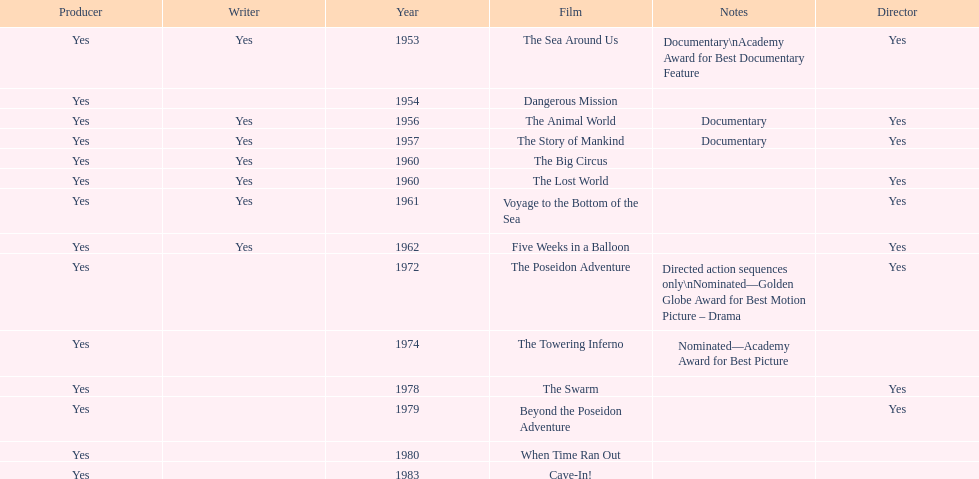How many films did irwin allen direct, produce and write? 6. Can you give me this table as a dict? {'header': ['Producer', 'Writer', 'Year', 'Film', 'Notes', 'Director'], 'rows': [['Yes', 'Yes', '1953', 'The Sea Around Us', 'Documentary\\nAcademy Award for Best Documentary Feature', 'Yes'], ['Yes', '', '1954', 'Dangerous Mission', '', ''], ['Yes', 'Yes', '1956', 'The Animal World', 'Documentary', 'Yes'], ['Yes', 'Yes', '1957', 'The Story of Mankind', 'Documentary', 'Yes'], ['Yes', 'Yes', '1960', 'The Big Circus', '', ''], ['Yes', 'Yes', '1960', 'The Lost World', '', 'Yes'], ['Yes', 'Yes', '1961', 'Voyage to the Bottom of the Sea', '', 'Yes'], ['Yes', 'Yes', '1962', 'Five Weeks in a Balloon', '', 'Yes'], ['Yes', '', '1972', 'The Poseidon Adventure', 'Directed action sequences only\\nNominated—Golden Globe Award for Best Motion Picture – Drama', 'Yes'], ['Yes', '', '1974', 'The Towering Inferno', 'Nominated—Academy Award for Best Picture', ''], ['Yes', '', '1978', 'The Swarm', '', 'Yes'], ['Yes', '', '1979', 'Beyond the Poseidon Adventure', '', 'Yes'], ['Yes', '', '1980', 'When Time Ran Out', '', ''], ['Yes', '', '1983', 'Cave-In!', '', '']]} 